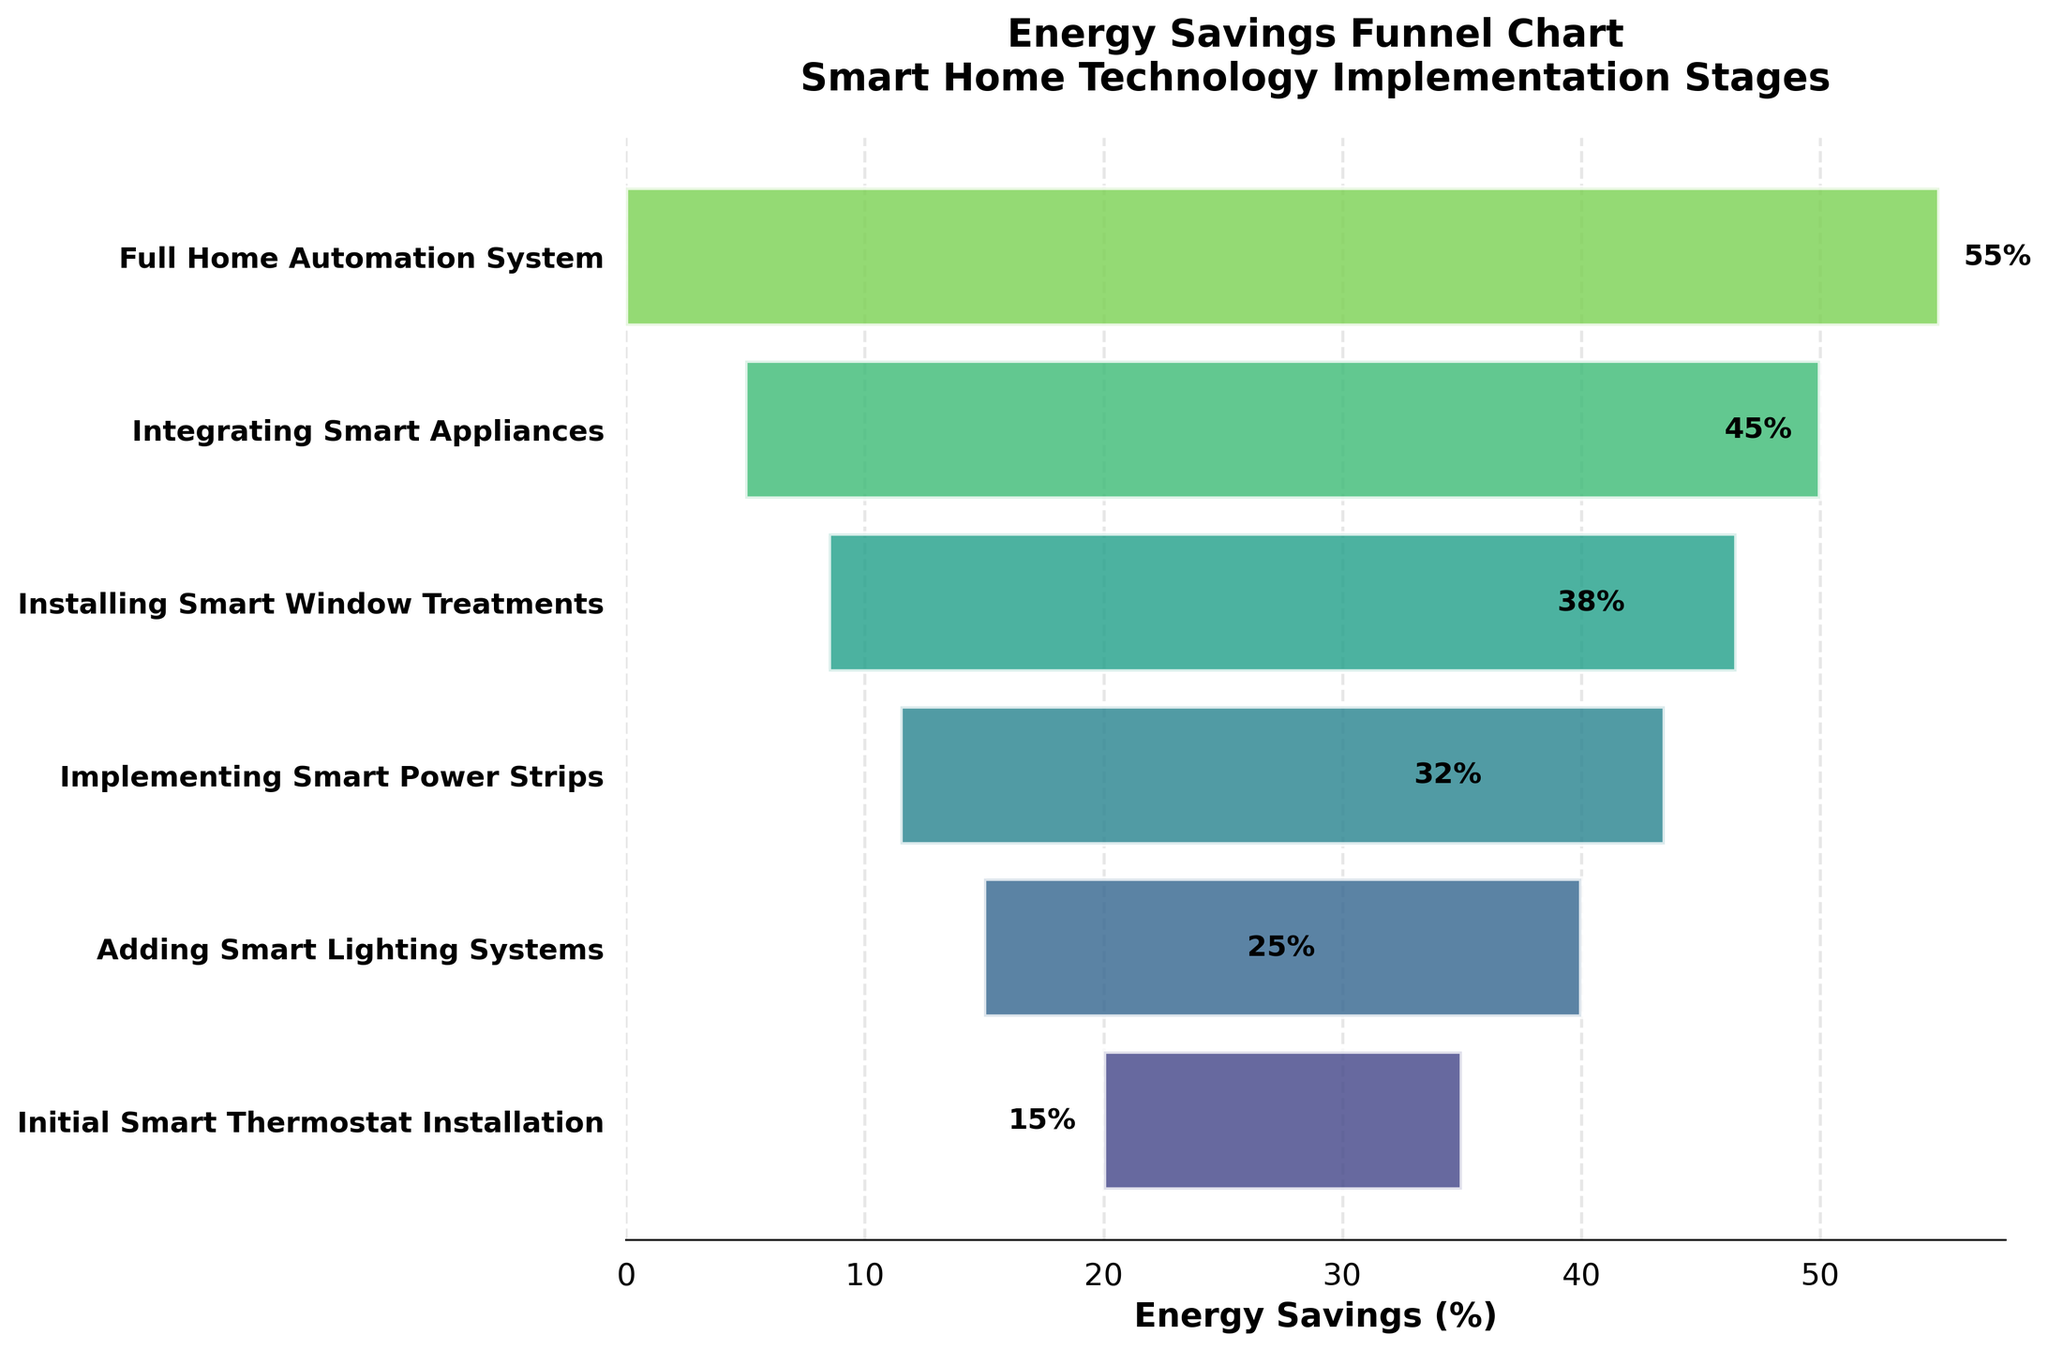What is the title of the funnel chart? The title of the funnel chart is located at the top and provides a summary of what the chart is about. In this case, the title reads "Energy Savings Funnel Chart\nSmart Home Technology Implementation Stages".
Answer: Energy Savings Funnel Chart\nSmart Home Technology Implementation Stages Which stage shows the highest energy savings percentage? To identify the stage with the highest energy savings, examine the rightmost bar in the funnel chart. The stage corresponding to this bar is labeled "Full Home Automation System," and the percentage is 55%.
Answer: Full Home Automation System How many implementation stages are shown in the chart? Count the number of bars or stages labeled on the y-axis of the funnel chart. There are six stages listed, ranging from "Initial Smart Thermostat Installation" to "Full Home Automation System".
Answer: 6 By how much do energy savings increase from adding Smart Lighting Systems to Implementing Smart Power Strips? Locate the energy savings percentages for both stages and find the difference between them. "Adding Smart Lighting Systems" has 25% savings, and "Implementing Smart Power Strips" has 32% savings. Subtract 25% from 32% to get the increase.
Answer: 7% What is the average energy savings percentage across all implementation stages? To find the average, sum up the energy savings percentages of all stages and divide by the number of stages. The stages have 15%, 25%, 32%, 38%, 45%, and 55%. The sum is 210%, and dividing this by 6 yields the average savings.
Answer: 35% Which implementation stage contributes the most additional energy savings compared to the previous stage? Calculate the differences in energy savings between consecutive stages and determine the largest difference. Comparing 15%, 25%, 32%, 38%, 45%, and 55%, the largest additional savings is from "Adding Smart Lighting Systems" increasing by 10% (from 15% to 25%).
Answer: Adding Smart Lighting Systems What's the total energy savings percentage from Implementing Smart Power Strips to Full Home Automation System? Add the energy savings percentages for "Implementing Smart Power Strips" (32%), "Installing Smart Window Treatments" (38%), "Integrating Smart Appliances" (45%), and "Full Home Automation System" (55%). The total is 32% + 38% + 45% + 55%.
Answer: 170% Which stage follows implementing Smart Power Strips? Find the bar labeled "Implementing Smart Power Strips," then identify the stage directly below it. The next stage in the sequence is "Installing Smart Window Treatments".
Answer: Installing Smart Window Treatments How does the energy savings percentage of the Initial Smart Thermostat Installation compare to the Full Home Automation System? Compare the energy savings percentages of these two stages. "Initial Smart Thermostat Installation" has 15%, and "Full Home Automation System" has 55%. The savings from full automation are clearly higher.
Answer: Full Home Automation System has 40% more savings What percentage energy savings do you have if you stopped after installing Smart Window Treatments? Look at the energy savings percentage next to "Installing Smart Window Treatments." This value indicates the savings at this stage, which is 38%.
Answer: 38% 